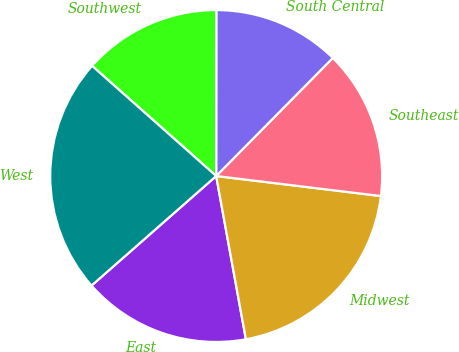Convert chart. <chart><loc_0><loc_0><loc_500><loc_500><pie_chart><fcel>East<fcel>Midwest<fcel>Southeast<fcel>South Central<fcel>Southwest<fcel>West<nl><fcel>16.39%<fcel>20.21%<fcel>14.52%<fcel>12.39%<fcel>13.46%<fcel>23.03%<nl></chart> 